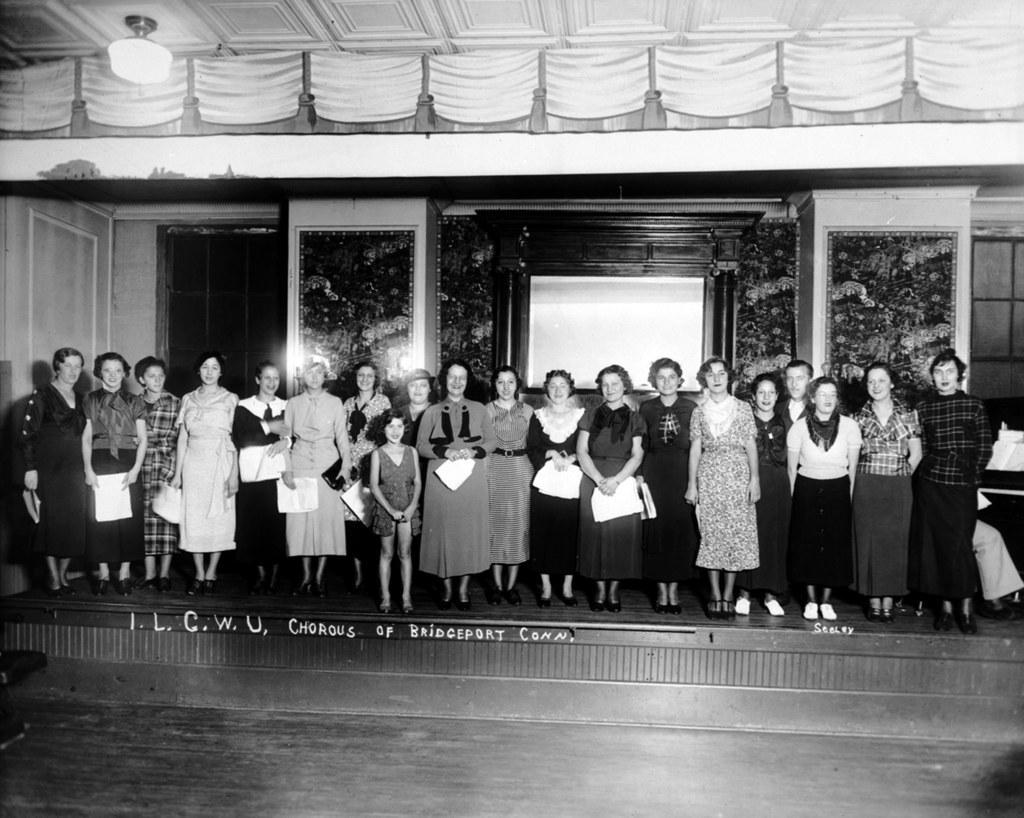Describe this image in one or two sentences. This is a black and white image of group of people standing on the stage and smiling, and there is a light, frames attached to the wall. 